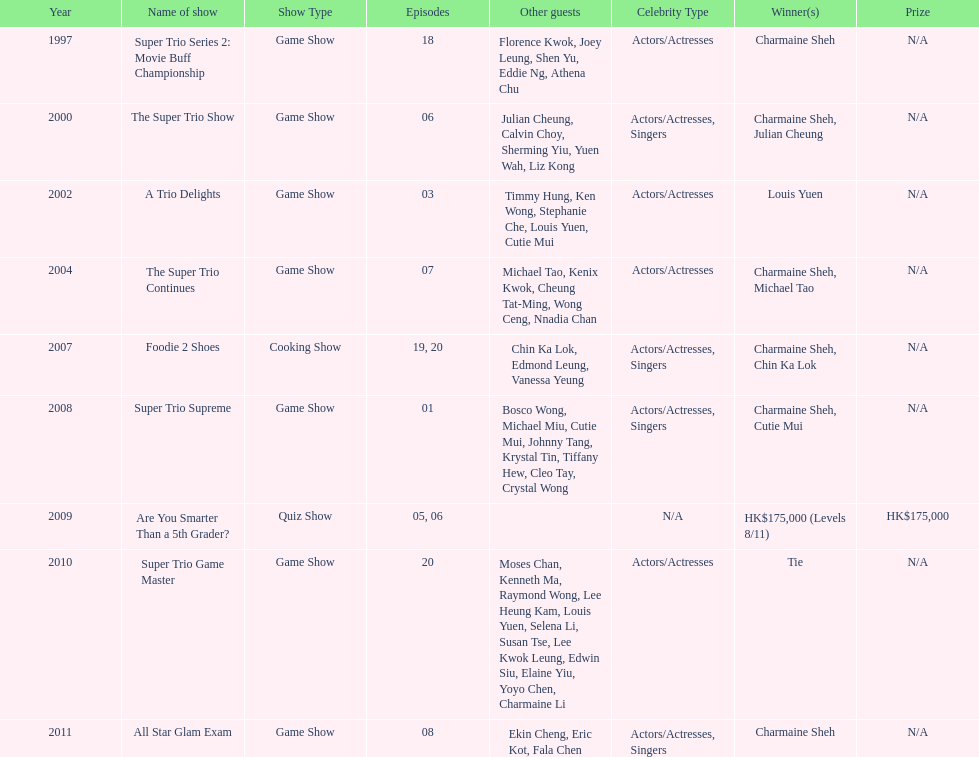In the variety show super trio 2: movie buff champions, how many episodes featured charmaine sheh? 18. 